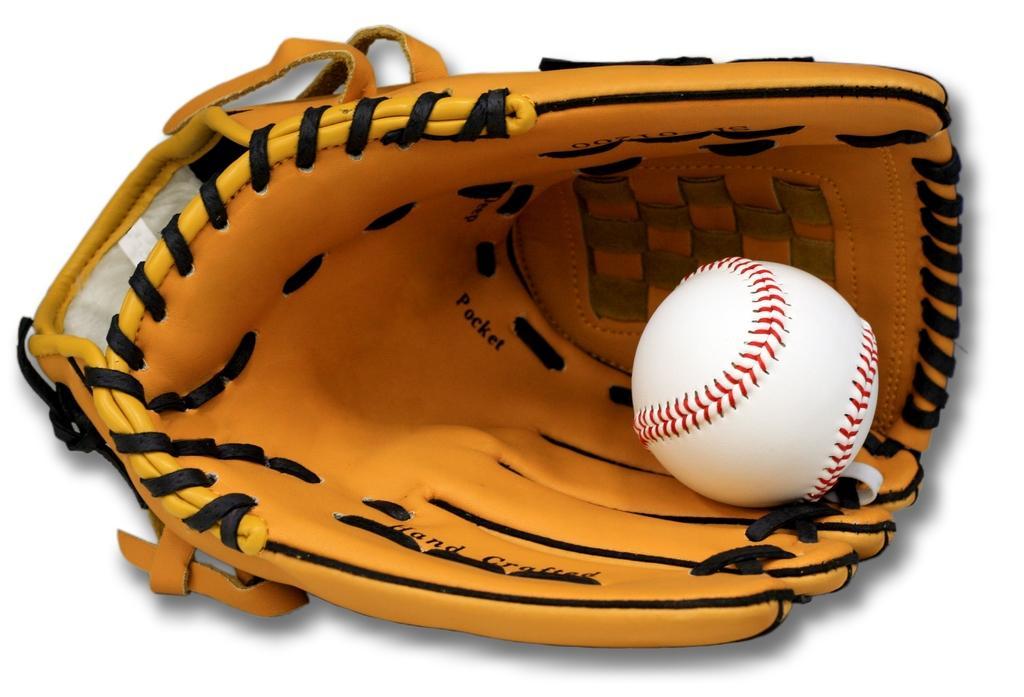Can you describe this image briefly? In this image, we can see a baseball glove and a ball. 